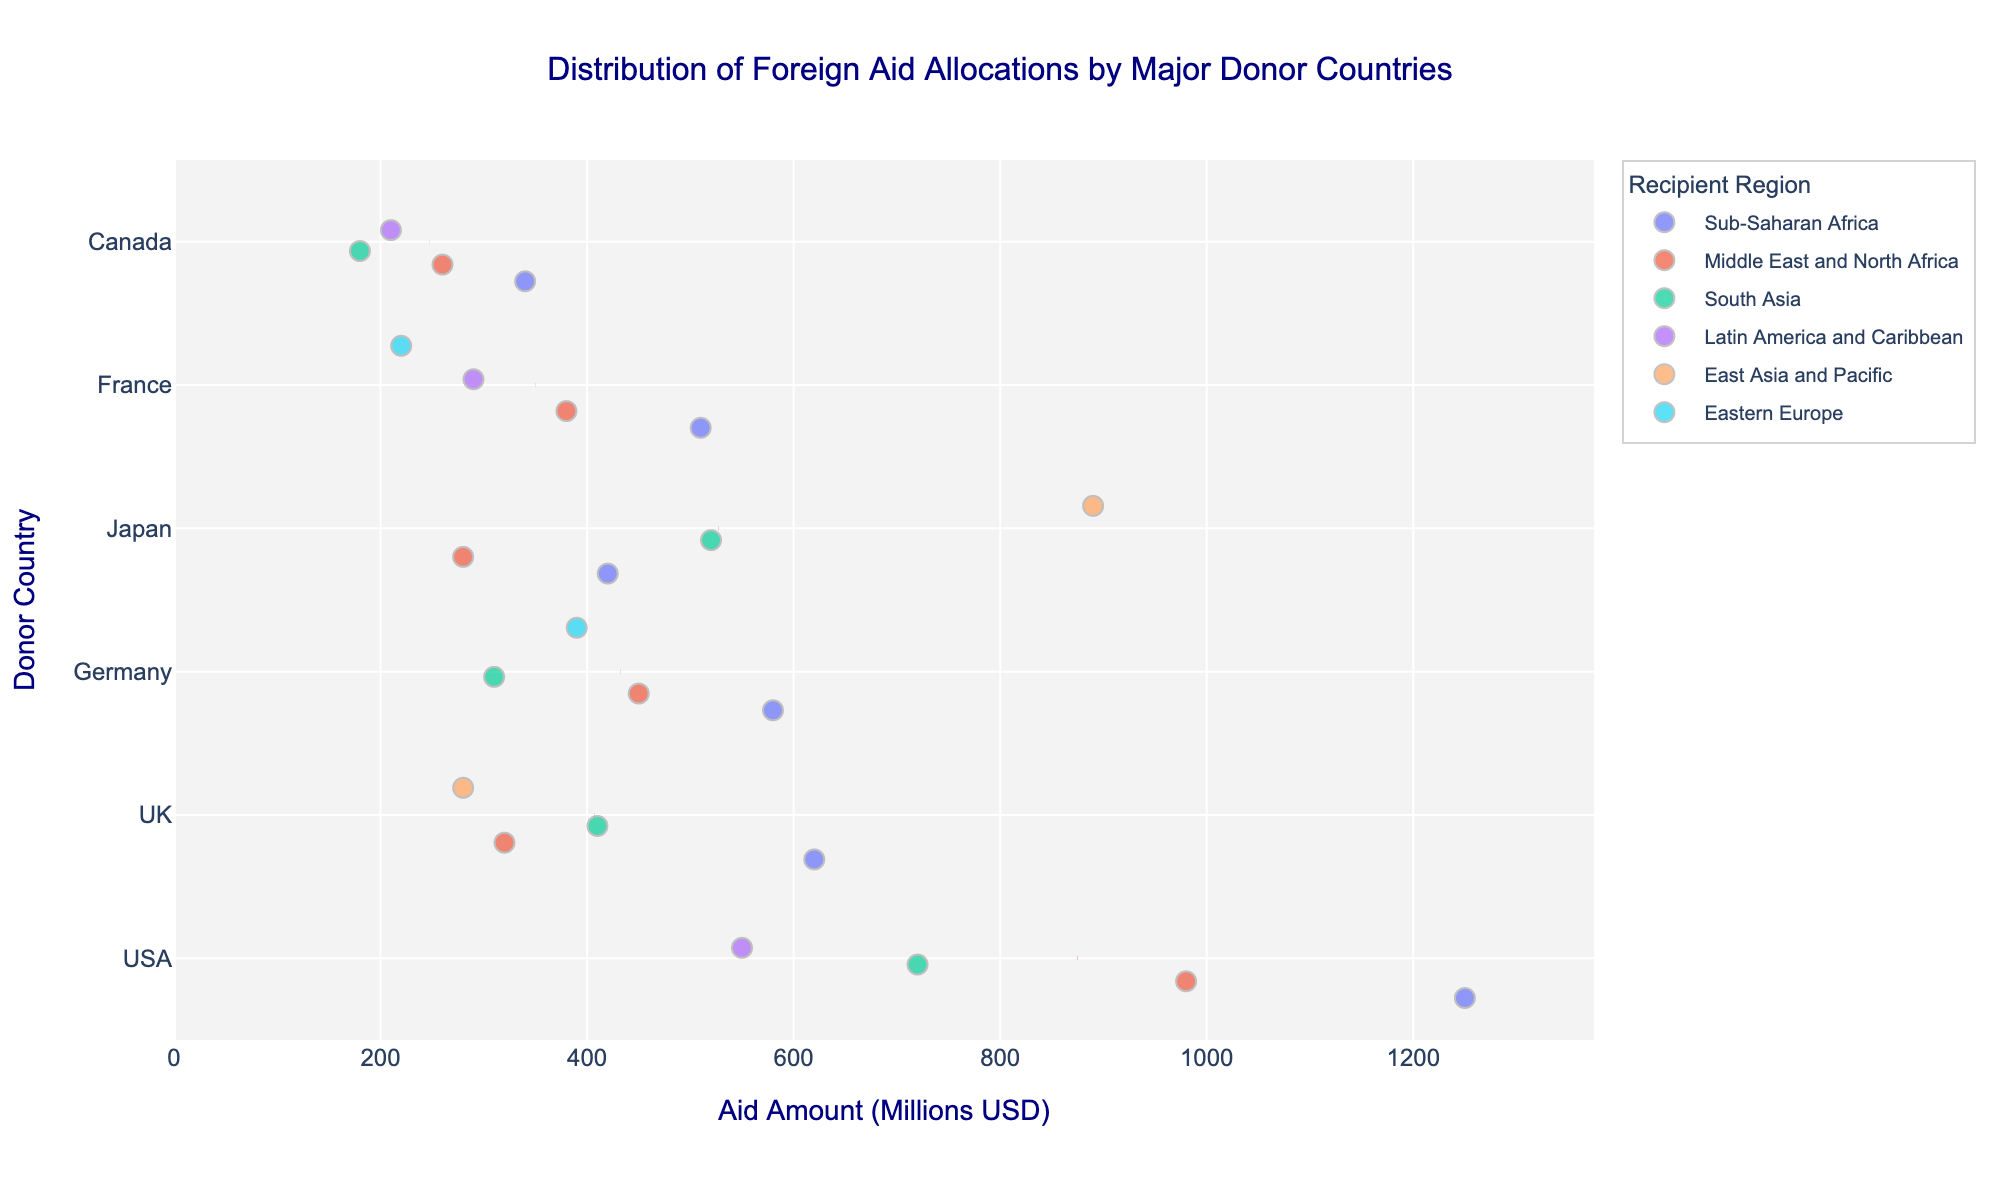What is the overall distribution of aid amounts from the USA to different recipient regions? The strip plot shows several points under the USA, each representing different recipient regions. The distribution of points indicates the aid varies from around 550 million USD to 1250 million USD. Key regions include Sub-Saharan Africa, Middle East and North Africa, South Asia, and Latin America and Caribbean.
Answer: 550 to 1250 million USD Which donor country has provided the highest single aid amount and to which region? By observing the individual points on the strip plot, Japan's East Asia and Pacific region has the highest single aid amount at 890 million USD.
Answer: Japan to East Asia and Pacific Which recipient region received the most foreign aid on average from donor countries? To find the average aid received by each region, consider the concentration and spread of points. Sub-Saharan Africa appears frequently among the top amounts from various donors, indicating a higher average.
Answer: Sub-Saharan Africa How does the aid distribution for the UK compare with aid distribution for Germany? The strip plot shows that the UK's aid is distributed across regions like Sub-Saharan Africa, South Asia, Middle East and North Africa, and East Asia and Pacific, with the highest at 620 million USD. Germany's aid is also spread out among similar regions, but its highest aid goes to Sub-Saharan Africa at 580 million USD. The distributions are somewhat similar, but the UK has a slightly higher range.
Answer: UK has a higher range than Germany What is the mean aid amount given by Canada to various regions? Sum up the aid amounts from Canada: 340, 260, 210, and 180, which totals to 990 million USD. Then, divide by the number of points (4): 990/4.
Answer: 247.5 million USD Which donor has the most consistent range of aid amounts across different regions? The consistency can be measured by the closeness of aid amounts across different regions. France's aid amounts range from 220 to 510 million USD, and all are fairly close, indicating consistency.
Answer: France What is the difference between the highest and lowest aid amounts given by Japan? The highest amount given by Japan is 890 million USD (East Asia and Pacific) and the lowest is 280 million USD (Middle East and North Africa). The difference is calculated as 890 - 280.
Answer: 610 million USD How is the distribution of aid from the USA different from that of France? The USA distributions are more spread out with higher values, up to 1250 million USD, while France has a narrower distribution capped around 510 million USD. The USA aids more across different regions and higher amounts.
Answer: USA has higher and more spread out aid amounts What is the sum of aid amounts provided by Germany to Sub-Saharan Africa and South Asia? Germany's aid amounts to Sub-Saharan Africa and South Asia are 580 million USD and 310 million USD respectively. The sum is calculated as 580 + 310.
Answer: 890 million USD Which recipient region has the highest variation in aid received from different donors? The region with the highest variation can be seen from the spread of points. Sub-Saharan Africa shows the spread from 1250 million USD (USA) to around 340 million USD (Canada). This indicates high variability.
Answer: Sub-Saharan Africa 